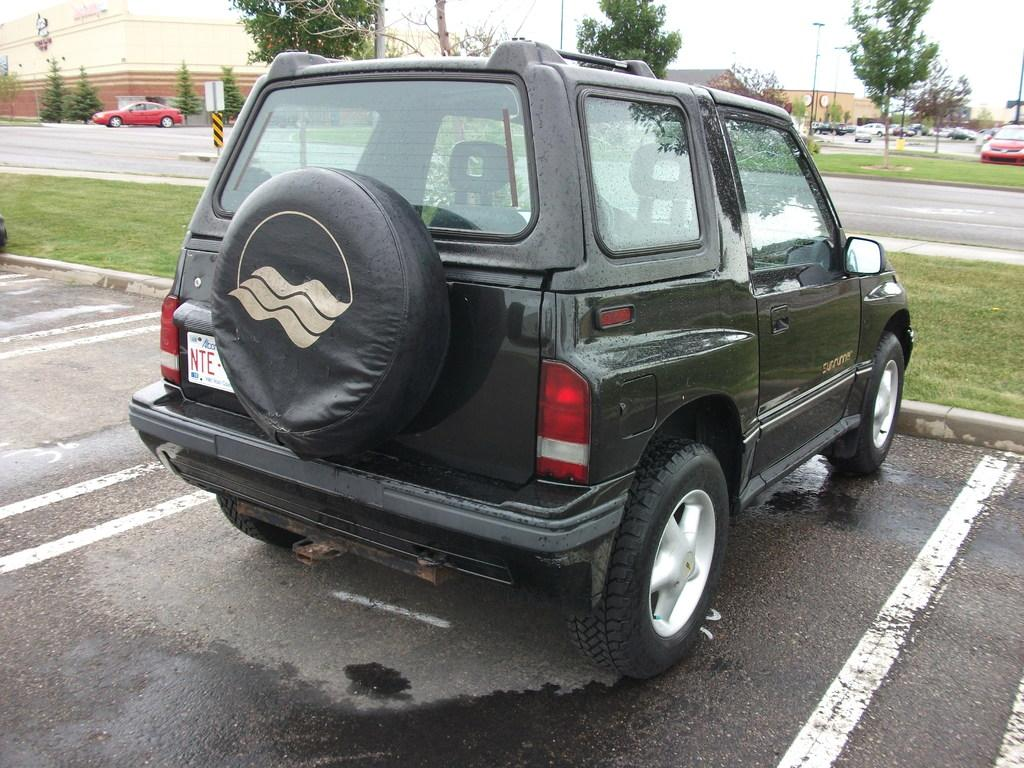What type of infrastructure is visible in the image? There are roads in the image. What is moving along the roads in the image? There are vehicles on the roads in the image. What can be seen in the background of the image? There are trees and houses in the background of the image. What type of silk is being used to make the houses in the image? There is no silk present in the image, and the houses are not made of silk. 